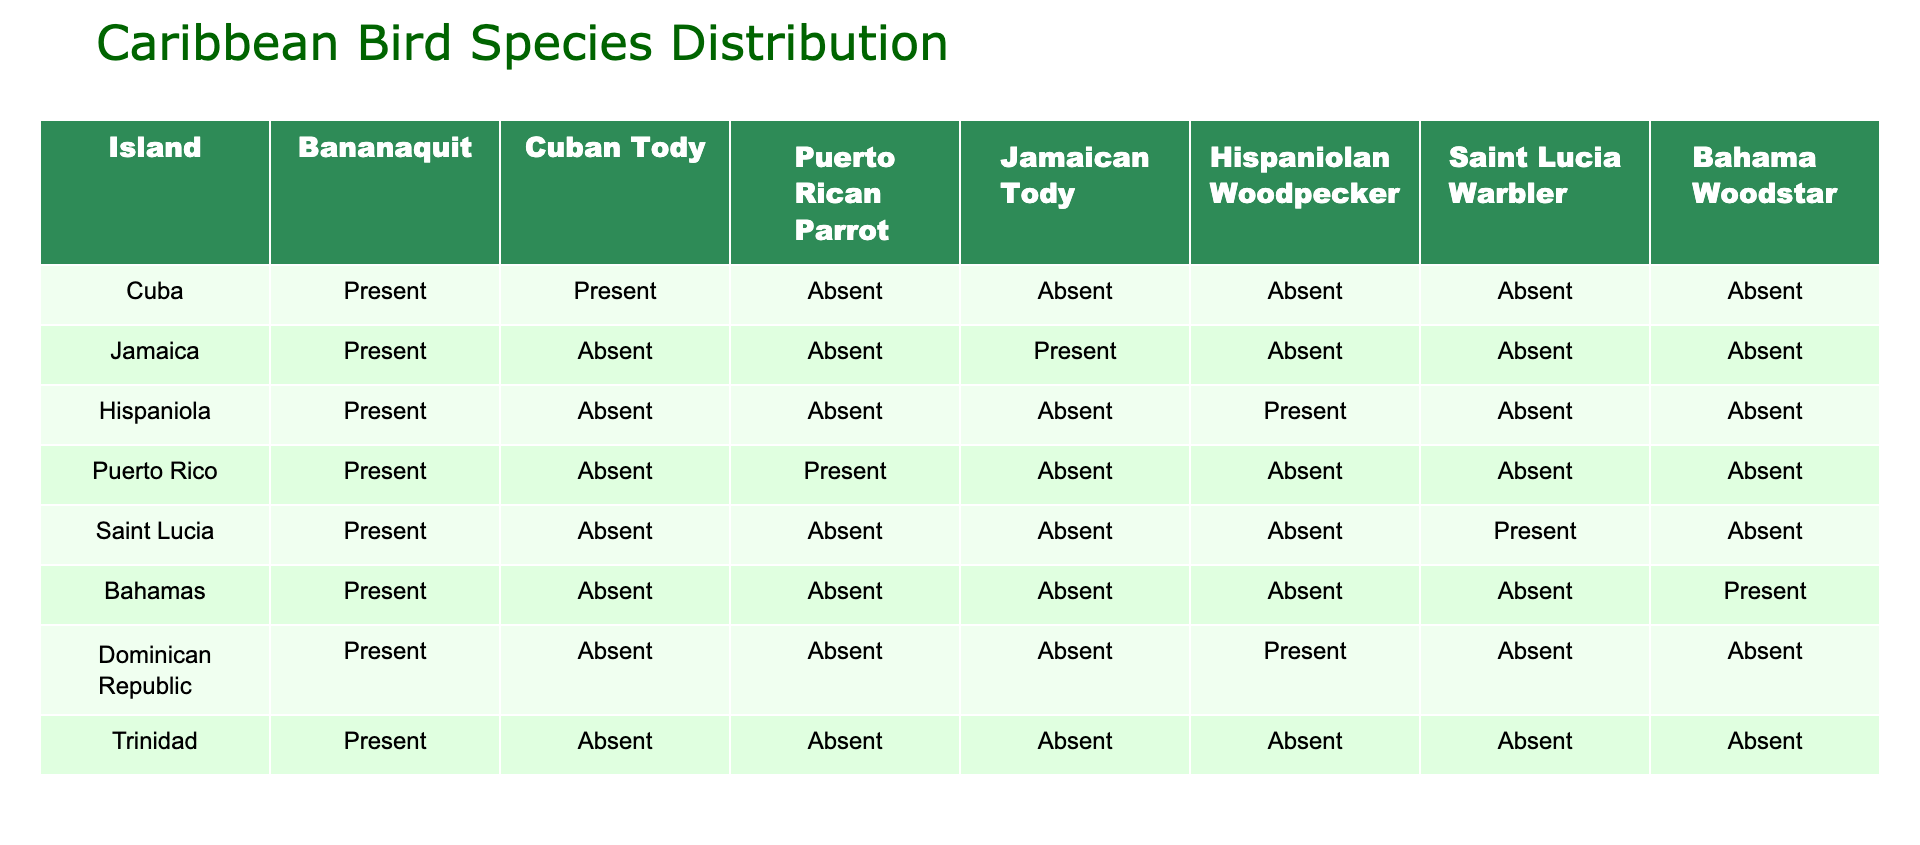What islands have the Cuban Tody? The Cuban Tody is marked as "Present" on the island of Cuba. For the other islands, the table shows "Absent". This means only Cuba has the Cuban Tody among the islands listed.
Answer: Cuba Which island has the Puerto Rican Parrot? The Puerto Rican Parrot is "Present" only on Puerto Rico, as shown in the table. For all other islands, the status is marked "Absent".
Answer: Puerto Rico How many islands have the Bananaquit? Upon examining the table, the Bananaquit is "Present" on all islands listed, including Cuba, Jamaica, Hispaniola, Puerto Rico, Saint Lucia, Bahamas, Dominican Republic, and Trinidad. Adding these gives a total of 8 islands.
Answer: 8 Which bird species is present only on the island of Saint Lucia? The only species marked as "Present" solely on Saint Lucia and "Absent" on all other listed islands is the Saint Lucia Warbler.
Answer: Saint Lucia Warbler Is the Bahama Woodstar present in Puerto Rico? The table indicates that the Bahama Woodstar is marked "Absent" in Puerto Rico, confirming that it is not found there according to the data provided.
Answer: No How many species are present on Jamaica compared to Puerto Rico? On Jamaica, there are two species present (Bananaquit and Jamaican Tody) while Puerto Rico has two (Bananaquit and Puerto Rican Parrot). This shows that both islands have an equal number of species present which is two.
Answer: 2 Which island has both the Hispaniolan Woodpecker and the Jamaican Tody? The table shows that Hispaniola has the Hispaniolan Woodpecker marked "Present" but does not have the Jamaican Tody; Jamaica has the Jamaican Tody "Present" but lacks the Hispaniolan Woodpecker. Thus, no single island contains both species.
Answer: None What percentage of the islands have the Bahama Woodstar? The Bahama Woodstar is present on only one island, the Bahamas, among the eight islands in the data set. The calculation for the percentage is (1/8) * 100 which equals 12.5%.
Answer: 12.5% What is the species present on Hispaniola that is absent elsewhere? On Hispaniola, the Hispaniolan Woodpecker is marked as "Present", while it is "Absent" on all other islands, making it unique to that island according to the table.
Answer: Hispaniolan Woodpecker 